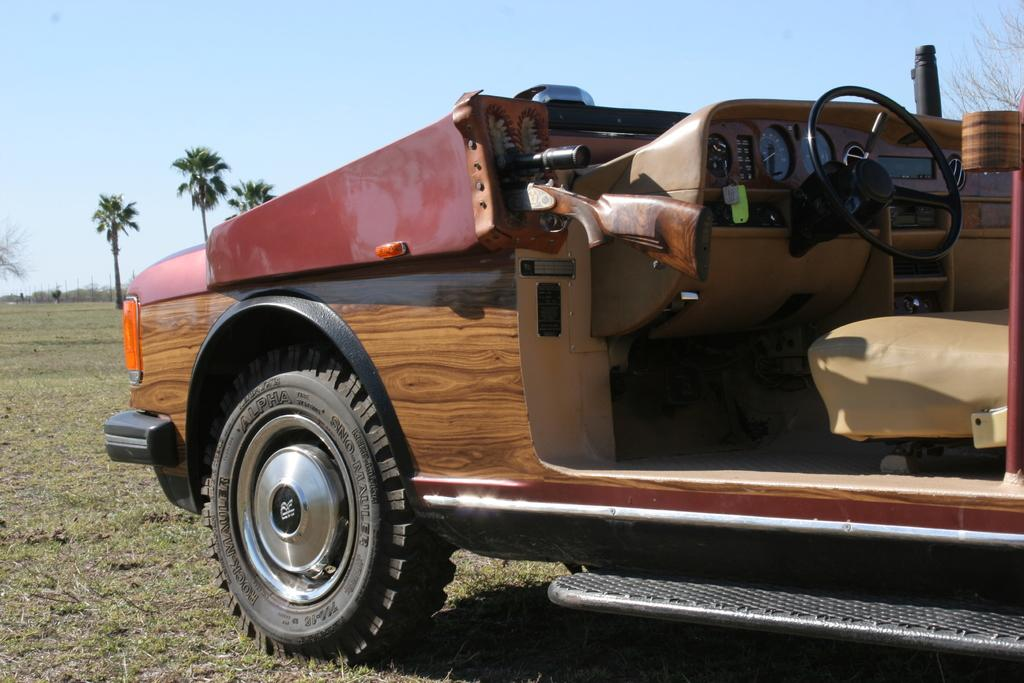What is the main subject in the image? There is a vehicle in the image. What can be seen on the left side of the image? There are trees on the left side of the image. What is visible in the background of the image? The sky is visible in the image. What type of terrain is present in the image? There is a grassy land in the image. How many apples are hanging from the trees in the image? There are no apples visible in the image; only trees are present on the left side. 